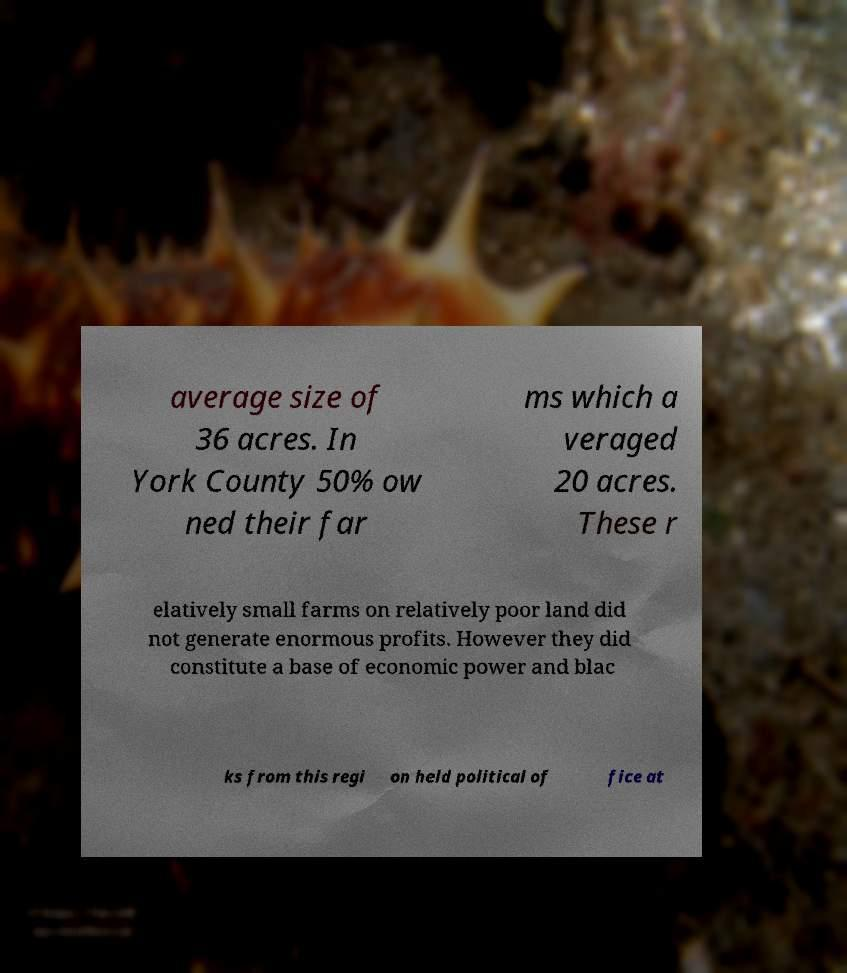Can you read and provide the text displayed in the image?This photo seems to have some interesting text. Can you extract and type it out for me? average size of 36 acres. In York County 50% ow ned their far ms which a veraged 20 acres. These r elatively small farms on relatively poor land did not generate enormous profits. However they did constitute a base of economic power and blac ks from this regi on held political of fice at 